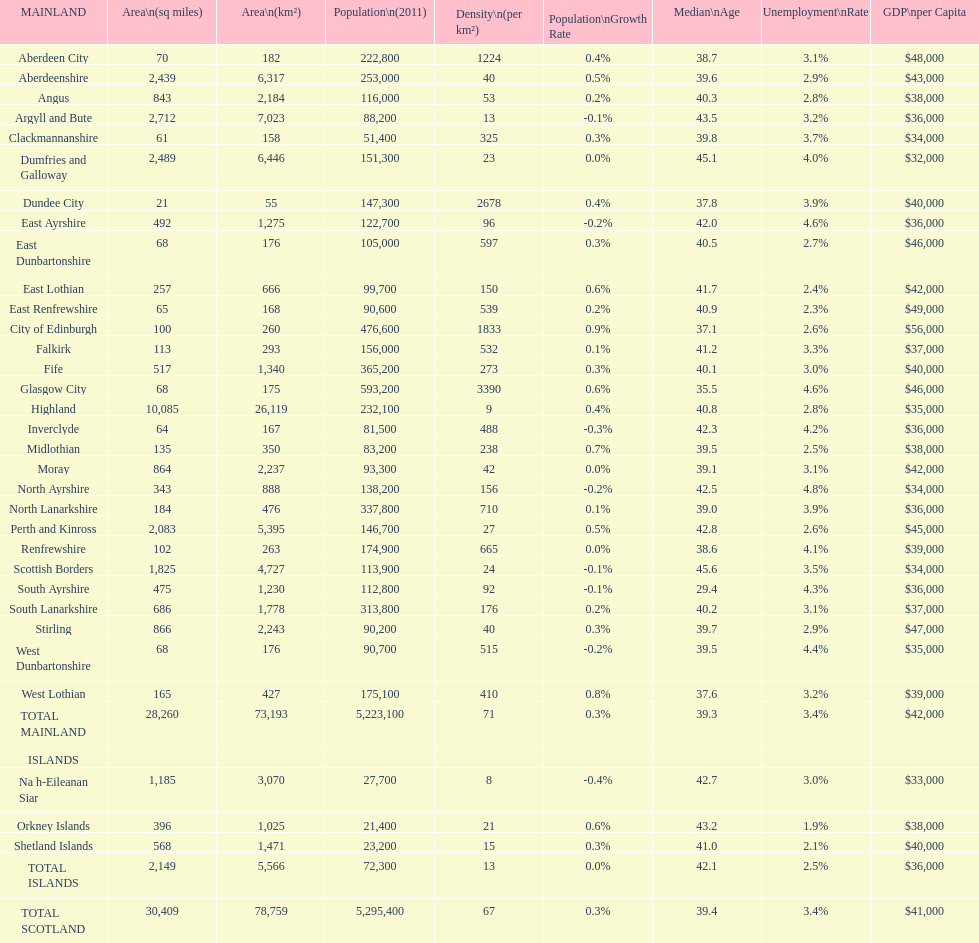What is the total area of east lothian, angus, and dundee city? 1121. 